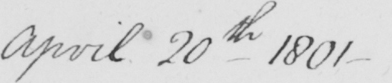Can you read and transcribe this handwriting? April 20th 1801 _ 